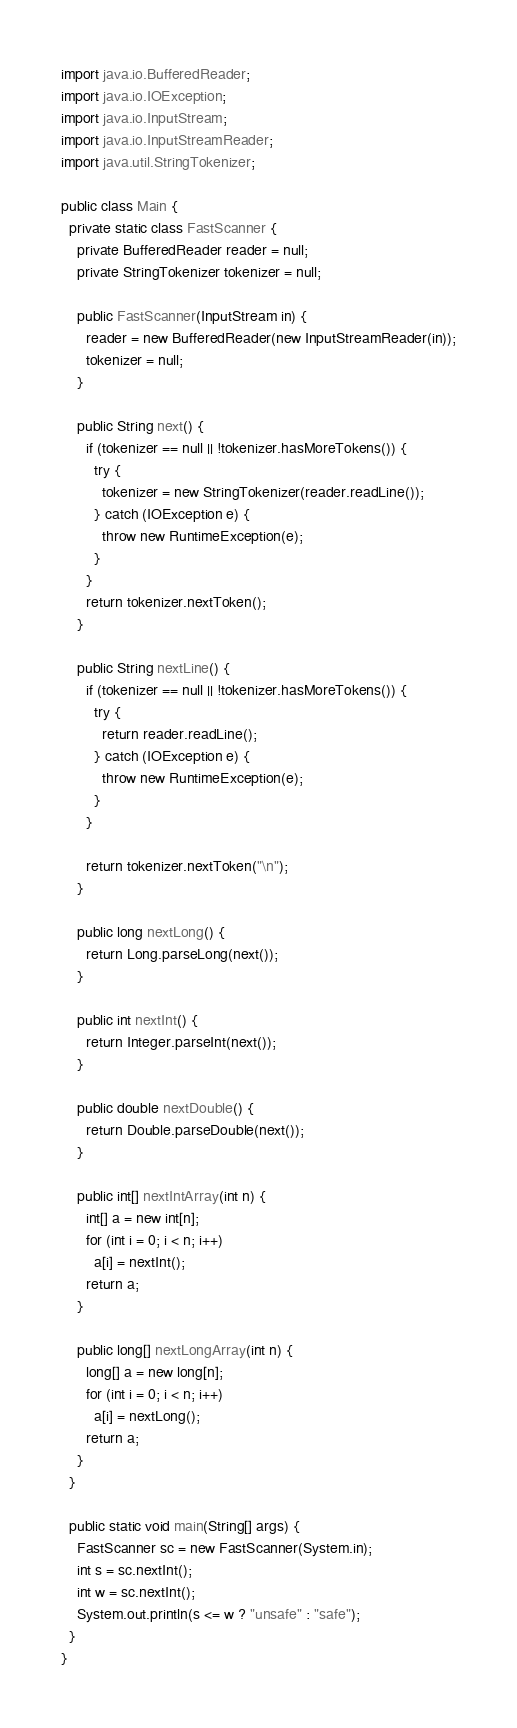<code> <loc_0><loc_0><loc_500><loc_500><_Java_>import java.io.BufferedReader;
import java.io.IOException;
import java.io.InputStream;
import java.io.InputStreamReader;
import java.util.StringTokenizer;

public class Main {
  private static class FastScanner {
    private BufferedReader reader = null;
    private StringTokenizer tokenizer = null;

    public FastScanner(InputStream in) {
      reader = new BufferedReader(new InputStreamReader(in));
      tokenizer = null;
    }

    public String next() {
      if (tokenizer == null || !tokenizer.hasMoreTokens()) {
        try {
          tokenizer = new StringTokenizer(reader.readLine());
        } catch (IOException e) {
          throw new RuntimeException(e);
        }
      }
      return tokenizer.nextToken();
    }

    public String nextLine() {
      if (tokenizer == null || !tokenizer.hasMoreTokens()) {
        try {
          return reader.readLine();
        } catch (IOException e) {
          throw new RuntimeException(e);
        }
      }

      return tokenizer.nextToken("\n");
    }

    public long nextLong() {
      return Long.parseLong(next());
    }

    public int nextInt() {
      return Integer.parseInt(next());
    }

    public double nextDouble() {
      return Double.parseDouble(next());
    }

    public int[] nextIntArray(int n) {
      int[] a = new int[n];
      for (int i = 0; i < n; i++)
        a[i] = nextInt();
      return a;
    }

    public long[] nextLongArray(int n) {
      long[] a = new long[n];
      for (int i = 0; i < n; i++)
        a[i] = nextLong();
      return a;
    }
  }

  public static void main(String[] args) {
    FastScanner sc = new FastScanner(System.in);
    int s = sc.nextInt();
    int w = sc.nextInt();
    System.out.println(s <= w ? "unsafe" : "safe");
  }
}</code> 